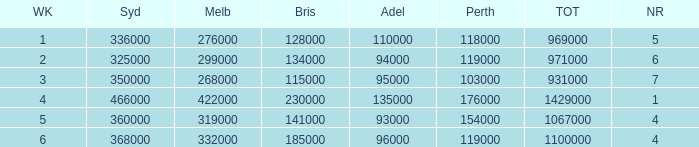What was the rating in Brisbane the week it was 276000 in Melbourne?  128000.0. Parse the table in full. {'header': ['WK', 'Syd', 'Melb', 'Bris', 'Adel', 'Perth', 'TOT', 'NR'], 'rows': [['1', '336000', '276000', '128000', '110000', '118000', '969000', '5'], ['2', '325000', '299000', '134000', '94000', '119000', '971000', '6'], ['3', '350000', '268000', '115000', '95000', '103000', '931000', '7'], ['4', '466000', '422000', '230000', '135000', '176000', '1429000', '1'], ['5', '360000', '319000', '141000', '93000', '154000', '1067000', '4'], ['6', '368000', '332000', '185000', '96000', '119000', '1100000', '4']]} 